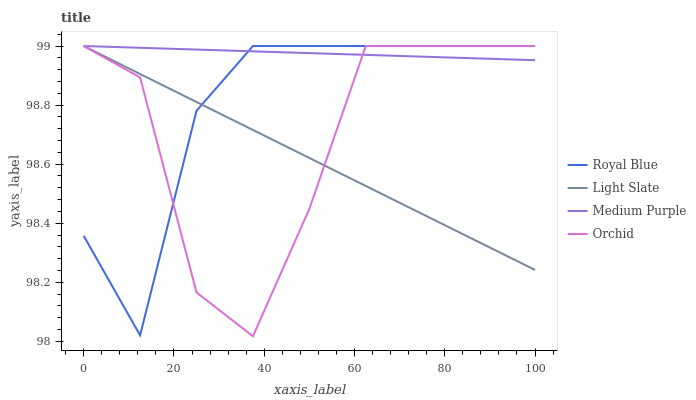Does Royal Blue have the minimum area under the curve?
Answer yes or no. No. Does Royal Blue have the maximum area under the curve?
Answer yes or no. No. Is Royal Blue the smoothest?
Answer yes or no. No. Is Royal Blue the roughest?
Answer yes or no. No. Does Royal Blue have the lowest value?
Answer yes or no. No. 